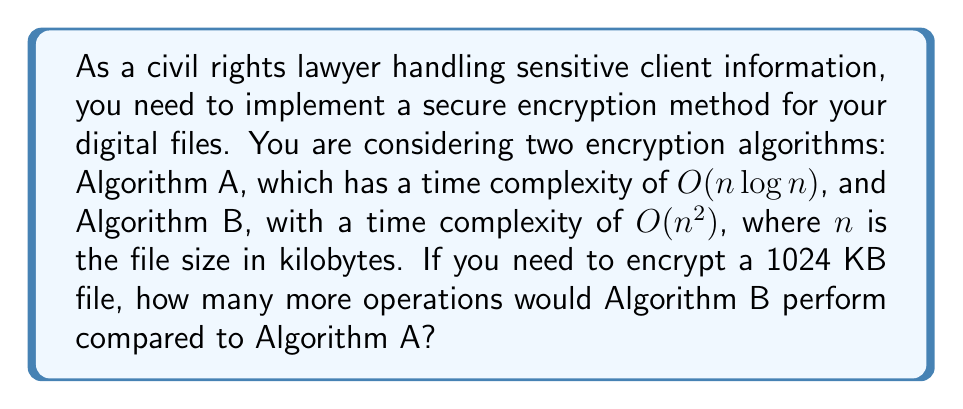Could you help me with this problem? To solve this problem, we need to compare the number of operations performed by each algorithm for a file size of 1024 KB. Let's approach this step-by-step:

1. For Algorithm A with $O(n \log n)$ complexity:
   - Number of operations $\approx k_1 \cdot n \log n$
   - $n = 1024$ KB
   - Operations $\approx k_1 \cdot 1024 \log 1024$
   - $\log 1024 = \log 2^{10} = 10$
   - Operations $\approx k_1 \cdot 1024 \cdot 10 = 10240k_1$

2. For Algorithm B with $O(n^2)$ complexity:
   - Number of operations $\approx k_2 \cdot n^2$
   - $n = 1024$ KB
   - Operations $\approx k_2 \cdot 1024^2 = 1048576k_2$

3. To find the difference in operations, we subtract:
   Difference $= 1048576k_2 - 10240k_1$

4. Assuming $k_1 \approx k_2 \approx k$ (as they are constants):
   Difference $\approx k(1048576 - 10240) = 1038336k$

Therefore, Algorithm B would perform approximately $1038336k$ more operations than Algorithm A, where $k$ is a constant factor.
Answer: Algorithm B would perform approximately $1038336k$ more operations than Algorithm A, where $k$ is a constant factor. 